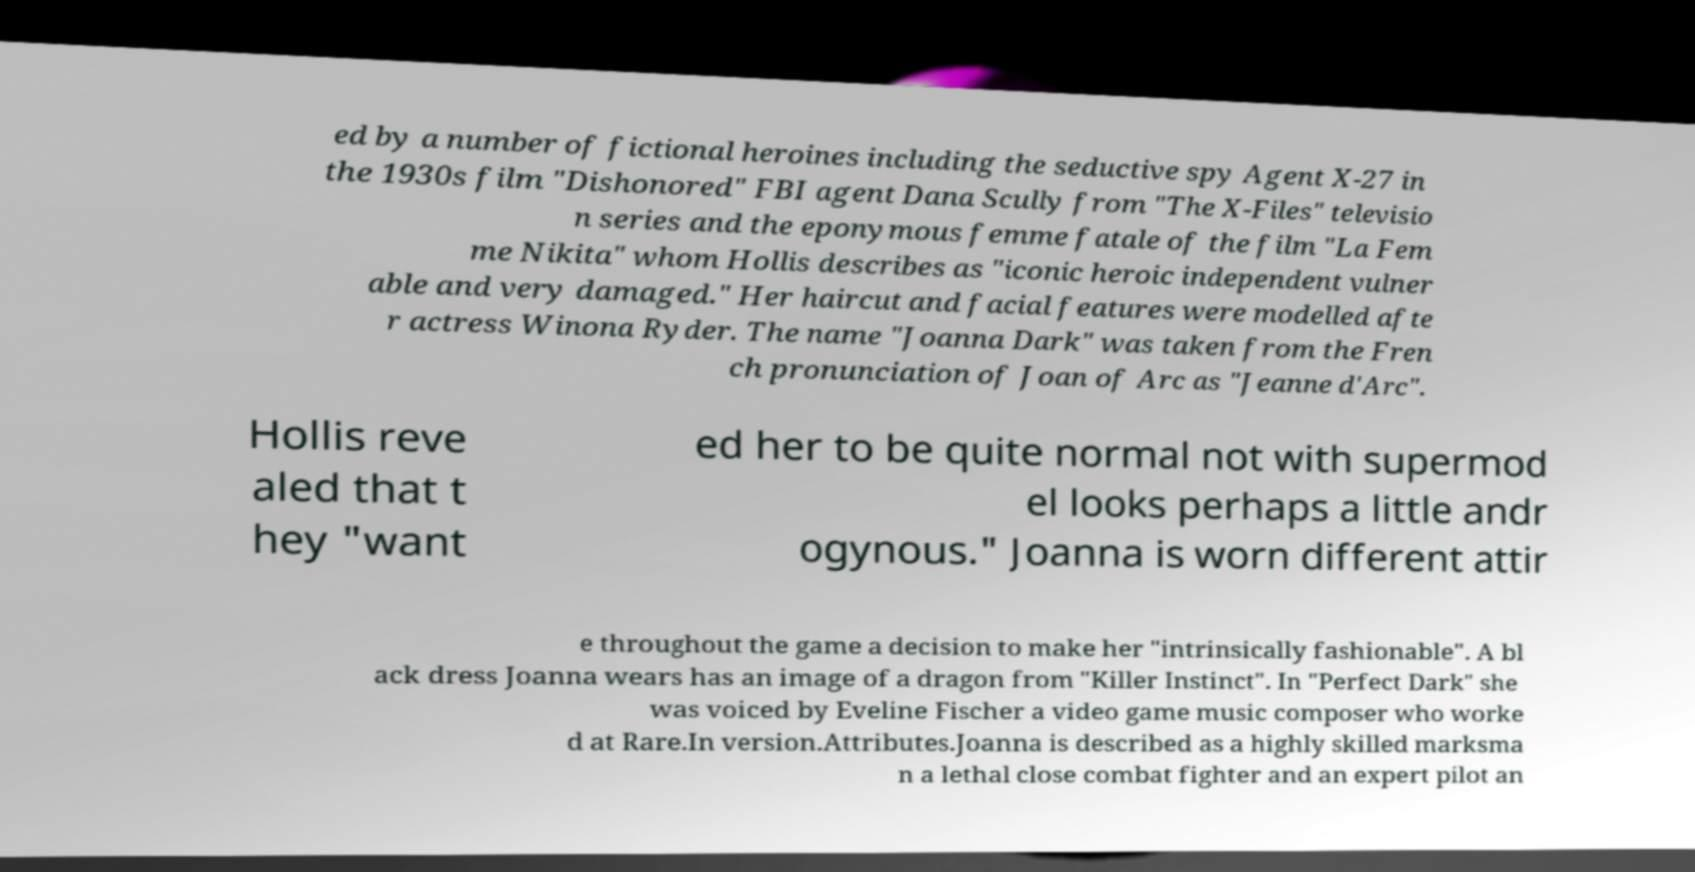Could you assist in decoding the text presented in this image and type it out clearly? ed by a number of fictional heroines including the seductive spy Agent X-27 in the 1930s film "Dishonored" FBI agent Dana Scully from "The X-Files" televisio n series and the eponymous femme fatale of the film "La Fem me Nikita" whom Hollis describes as "iconic heroic independent vulner able and very damaged." Her haircut and facial features were modelled afte r actress Winona Ryder. The name "Joanna Dark" was taken from the Fren ch pronunciation of Joan of Arc as "Jeanne d'Arc". Hollis reve aled that t hey "want ed her to be quite normal not with supermod el looks perhaps a little andr ogynous." Joanna is worn different attir e throughout the game a decision to make her "intrinsically fashionable". A bl ack dress Joanna wears has an image of a dragon from "Killer Instinct". In "Perfect Dark" she was voiced by Eveline Fischer a video game music composer who worke d at Rare.In version.Attributes.Joanna is described as a highly skilled marksma n a lethal close combat fighter and an expert pilot an 